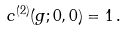<formula> <loc_0><loc_0><loc_500><loc_500>c ^ { ( 2 ) } ( g ; 0 , 0 ) = 1 \, .</formula> 